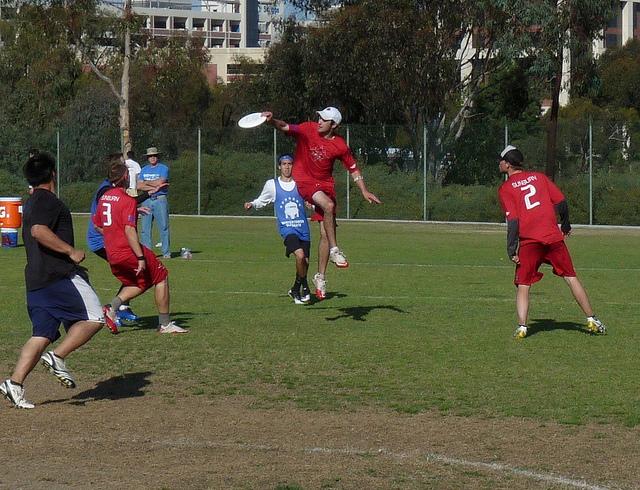What color is the line on the field next to the men?
Write a very short answer. White. What are the boys chasing after?
Write a very short answer. Frisbee. What is the most common colored Jersey in the picture?
Keep it brief. Red. What sport is this?
Short answer required. Frisbee. What sport are these men playing?
Write a very short answer. Frisbee. How many people are wearing red?
Quick response, please. 3. What sport is being played?
Write a very short answer. Frisbee. How many people are standing in front of the fence?
Write a very short answer. 7. How many teams are playing this sport?
Give a very brief answer. 2. Is this little league?
Answer briefly. No. Who took this picture?
Write a very short answer. Spectator. How many people in the shot?
Quick response, please. 8. Are the playing soccer?
Keep it brief. No. What number is on the red shirt?
Concise answer only. 2. Is there a player in the picture who might be injured?
Quick response, please. No. Which sport are they playing?
Answer briefly. Frisbee. Which game is this?
Answer briefly. Frisbee. What is the color of the uniform of the guy holding the frisbee?
Short answer required. Red. 